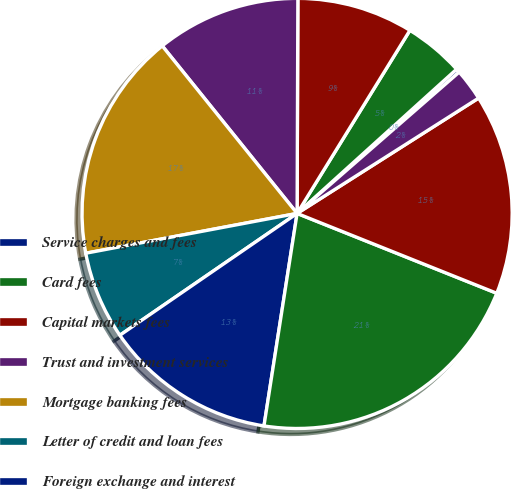<chart> <loc_0><loc_0><loc_500><loc_500><pie_chart><fcel>Service charges and fees<fcel>Card fees<fcel>Capital markets fees<fcel>Trust and investment services<fcel>Mortgage banking fees<fcel>Letter of credit and loan fees<fcel>Foreign exchange and interest<fcel>Securities gains net<fcel>Other income (1)<fcel>Noninterest income (2)<nl><fcel>0.29%<fcel>4.51%<fcel>8.73%<fcel>10.84%<fcel>17.17%<fcel>6.62%<fcel>12.95%<fcel>21.4%<fcel>15.06%<fcel>2.4%<nl></chart> 